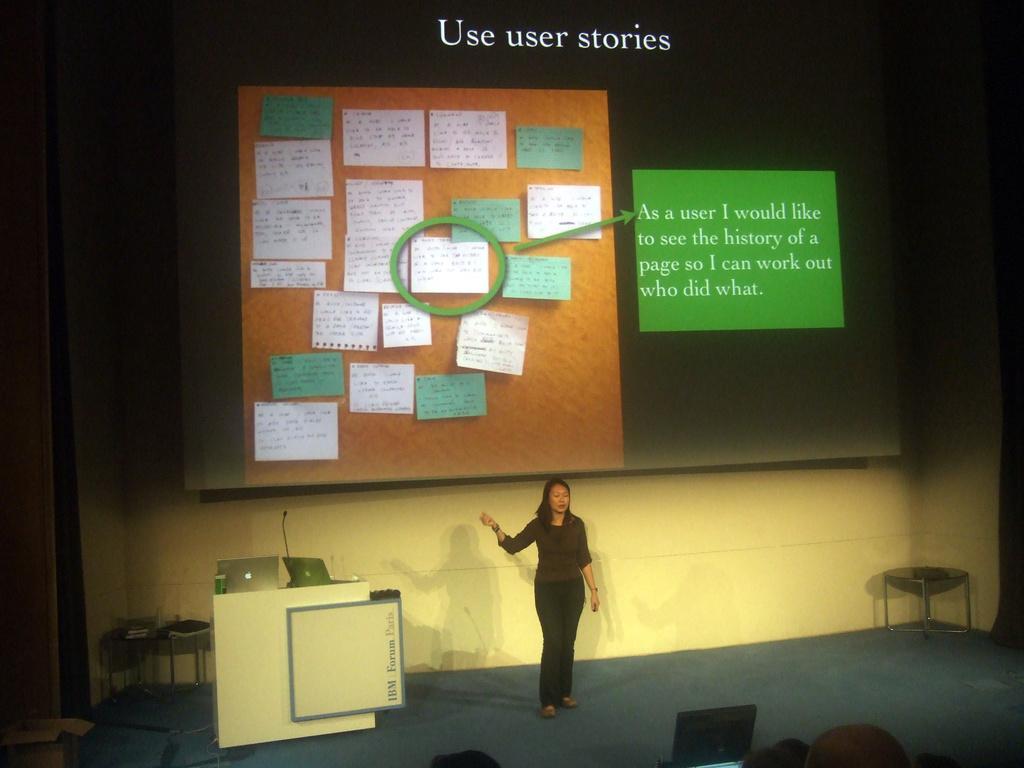In one or two sentences, can you explain what this image depicts? In this image, we can see a lady standing. We can see some tables with objects. Among them, we can see a table with laptops, a microphone. We can also see the ground. We can also see a projector screen with some text and posters displayed. We can see the wall. 